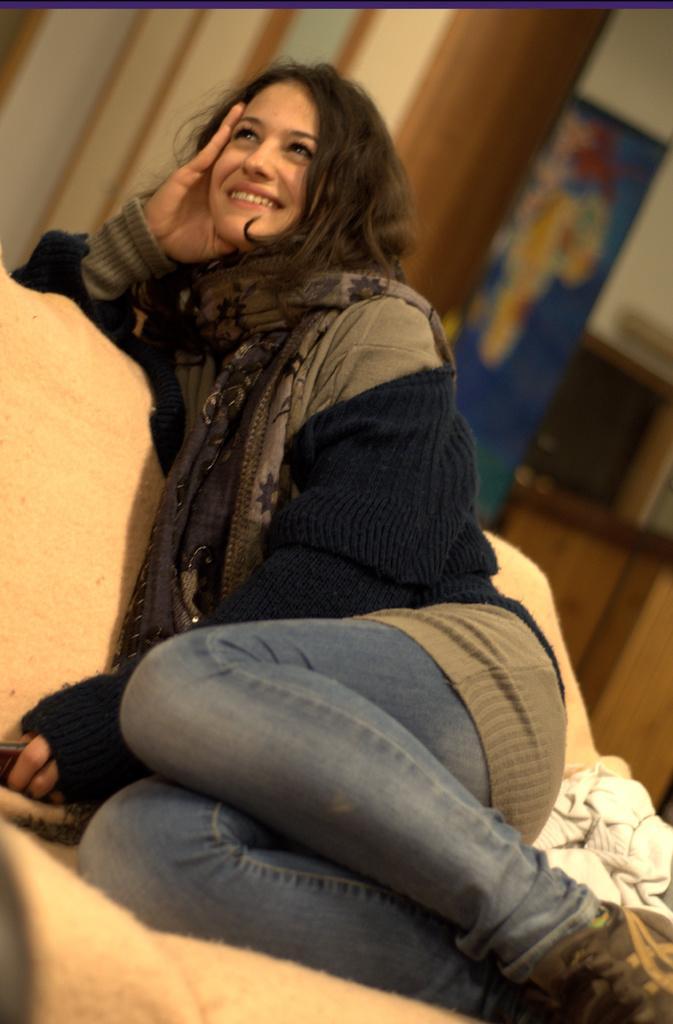Could you give a brief overview of what you see in this image? This woman wore jacket, scarf, smiling and looking upwards. Background it is blur. Far we can see a banner. 